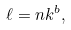Convert formula to latex. <formula><loc_0><loc_0><loc_500><loc_500>\ell = n k ^ { b } ,</formula> 